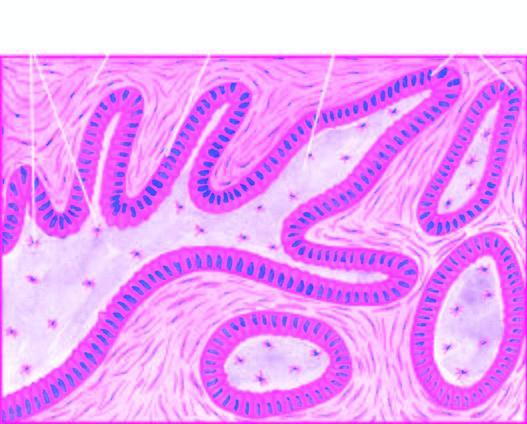re miliary composed of central area of stellate cells and peripheral layer of cuboidal or columnar cells?
Answer the question using a single word or phrase. No 